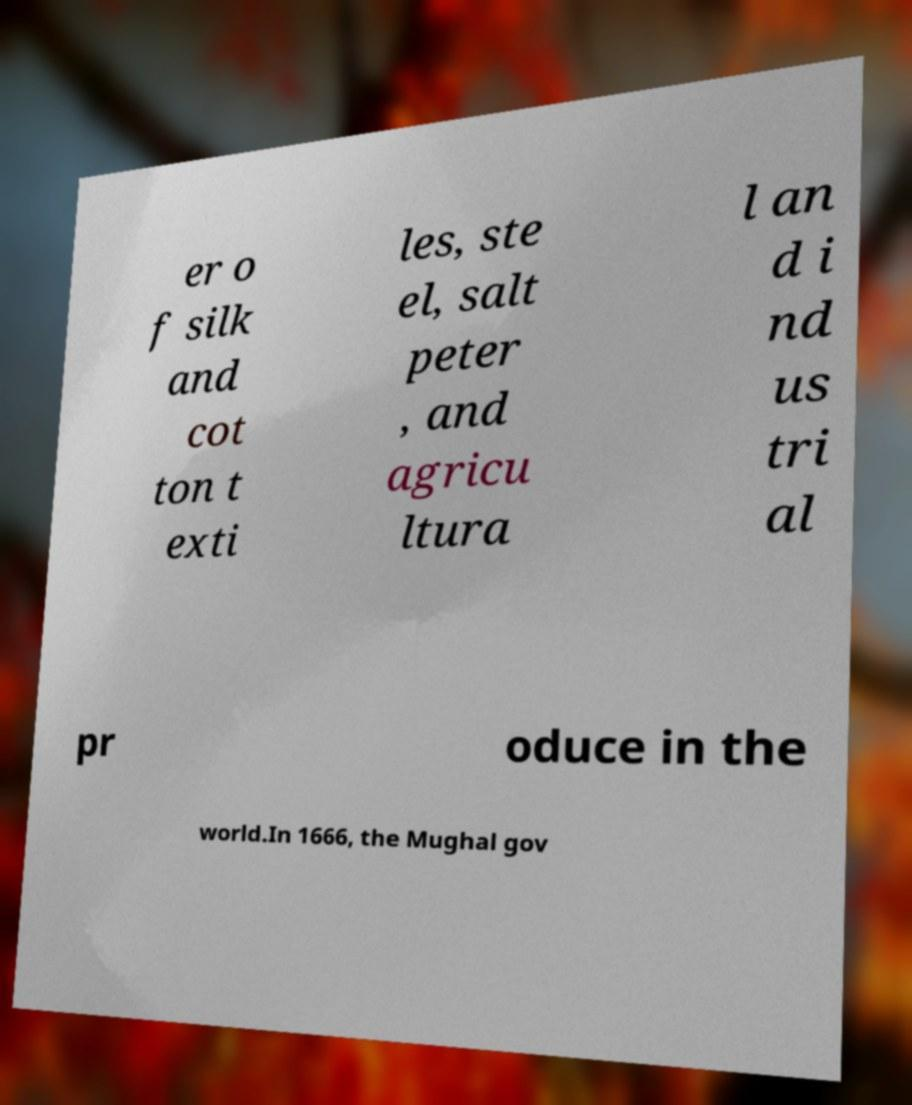Please read and relay the text visible in this image. What does it say? er o f silk and cot ton t exti les, ste el, salt peter , and agricu ltura l an d i nd us tri al pr oduce in the world.In 1666, the Mughal gov 